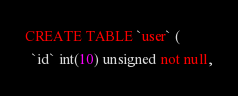<code> <loc_0><loc_0><loc_500><loc_500><_SQL_>CREATE TABLE `user` (
  `id` int(10) unsigned not null,</code> 